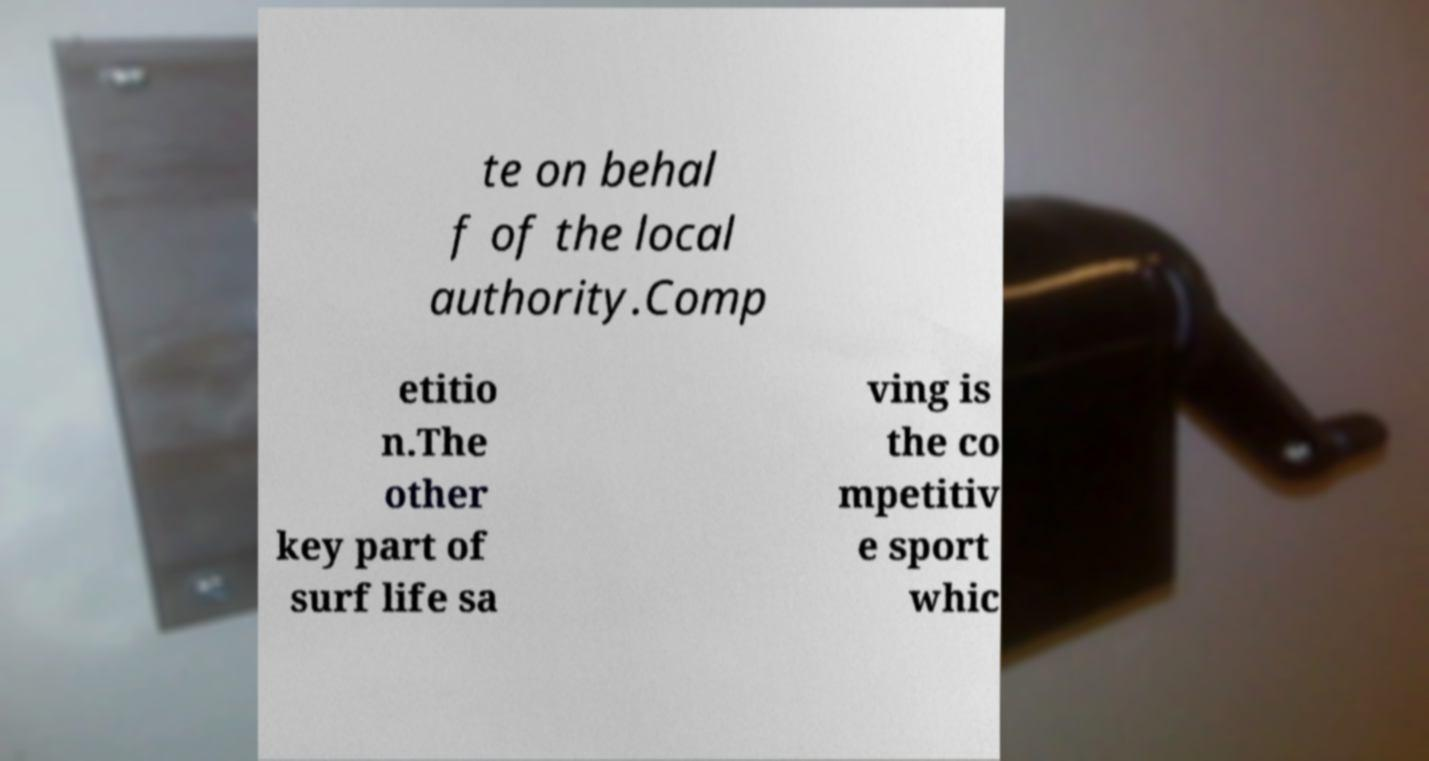There's text embedded in this image that I need extracted. Can you transcribe it verbatim? te on behal f of the local authority.Comp etitio n.The other key part of surf life sa ving is the co mpetitiv e sport whic 